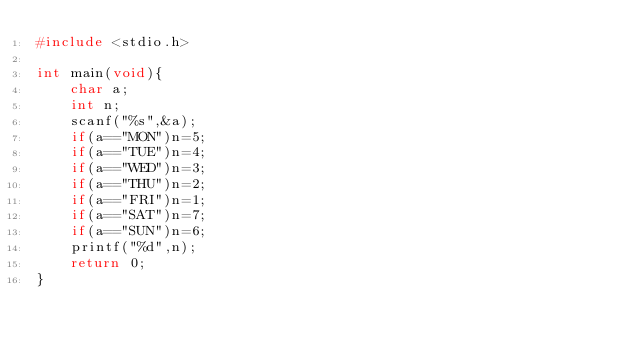Convert code to text. <code><loc_0><loc_0><loc_500><loc_500><_C_>#include <stdio.h>

int main(void){
    char a;
    int n;
    scanf("%s",&a);
    if(a=="MON")n=5;
    if(a=="TUE")n=4;
    if(a=="WED")n=3;
    if(a=="THU")n=2;
    if(a=="FRI")n=1;
    if(a=="SAT")n=7;
    if(a=="SUN")n=6;
    printf("%d",n);
    return 0;
}</code> 